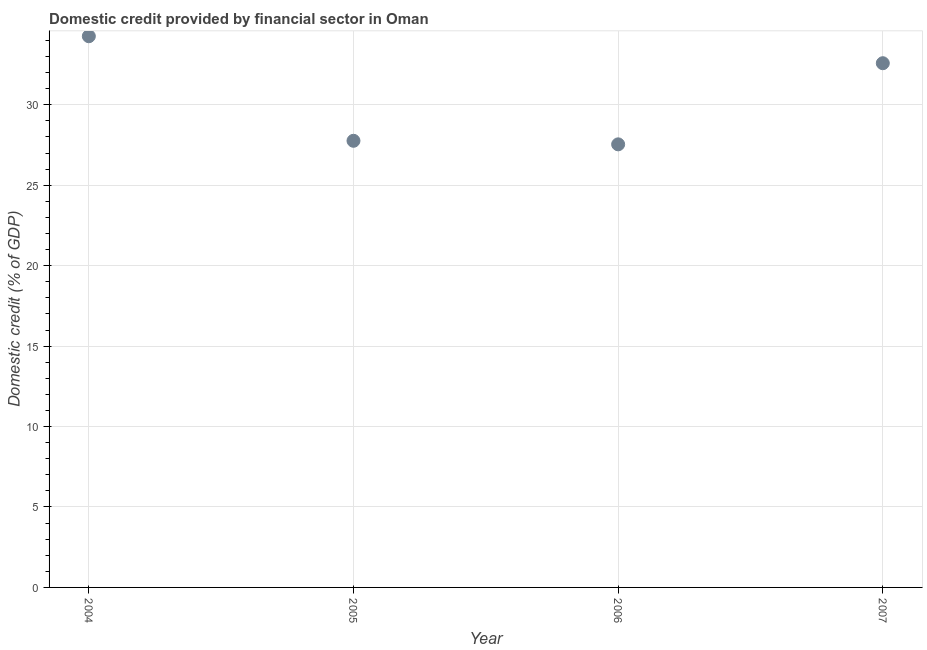What is the domestic credit provided by financial sector in 2004?
Your answer should be very brief. 34.26. Across all years, what is the maximum domestic credit provided by financial sector?
Your response must be concise. 34.26. Across all years, what is the minimum domestic credit provided by financial sector?
Keep it short and to the point. 27.54. In which year was the domestic credit provided by financial sector maximum?
Keep it short and to the point. 2004. In which year was the domestic credit provided by financial sector minimum?
Your answer should be very brief. 2006. What is the sum of the domestic credit provided by financial sector?
Provide a short and direct response. 122.15. What is the difference between the domestic credit provided by financial sector in 2005 and 2006?
Keep it short and to the point. 0.22. What is the average domestic credit provided by financial sector per year?
Make the answer very short. 30.54. What is the median domestic credit provided by financial sector?
Give a very brief answer. 30.17. What is the ratio of the domestic credit provided by financial sector in 2005 to that in 2007?
Make the answer very short. 0.85. What is the difference between the highest and the second highest domestic credit provided by financial sector?
Your answer should be very brief. 1.68. What is the difference between the highest and the lowest domestic credit provided by financial sector?
Give a very brief answer. 6.72. In how many years, is the domestic credit provided by financial sector greater than the average domestic credit provided by financial sector taken over all years?
Provide a short and direct response. 2. Does the domestic credit provided by financial sector monotonically increase over the years?
Your answer should be compact. No. How many dotlines are there?
Offer a very short reply. 1. What is the difference between two consecutive major ticks on the Y-axis?
Keep it short and to the point. 5. Are the values on the major ticks of Y-axis written in scientific E-notation?
Offer a terse response. No. Does the graph contain grids?
Offer a terse response. Yes. What is the title of the graph?
Offer a terse response. Domestic credit provided by financial sector in Oman. What is the label or title of the Y-axis?
Make the answer very short. Domestic credit (% of GDP). What is the Domestic credit (% of GDP) in 2004?
Ensure brevity in your answer.  34.26. What is the Domestic credit (% of GDP) in 2005?
Ensure brevity in your answer.  27.76. What is the Domestic credit (% of GDP) in 2006?
Ensure brevity in your answer.  27.54. What is the Domestic credit (% of GDP) in 2007?
Offer a very short reply. 32.58. What is the difference between the Domestic credit (% of GDP) in 2004 and 2005?
Offer a very short reply. 6.5. What is the difference between the Domestic credit (% of GDP) in 2004 and 2006?
Your answer should be very brief. 6.72. What is the difference between the Domestic credit (% of GDP) in 2004 and 2007?
Keep it short and to the point. 1.68. What is the difference between the Domestic credit (% of GDP) in 2005 and 2006?
Offer a terse response. 0.22. What is the difference between the Domestic credit (% of GDP) in 2005 and 2007?
Your response must be concise. -4.82. What is the difference between the Domestic credit (% of GDP) in 2006 and 2007?
Make the answer very short. -5.04. What is the ratio of the Domestic credit (% of GDP) in 2004 to that in 2005?
Make the answer very short. 1.23. What is the ratio of the Domestic credit (% of GDP) in 2004 to that in 2006?
Your response must be concise. 1.24. What is the ratio of the Domestic credit (% of GDP) in 2004 to that in 2007?
Your response must be concise. 1.05. What is the ratio of the Domestic credit (% of GDP) in 2005 to that in 2006?
Provide a short and direct response. 1.01. What is the ratio of the Domestic credit (% of GDP) in 2005 to that in 2007?
Offer a terse response. 0.85. What is the ratio of the Domestic credit (% of GDP) in 2006 to that in 2007?
Your answer should be very brief. 0.84. 